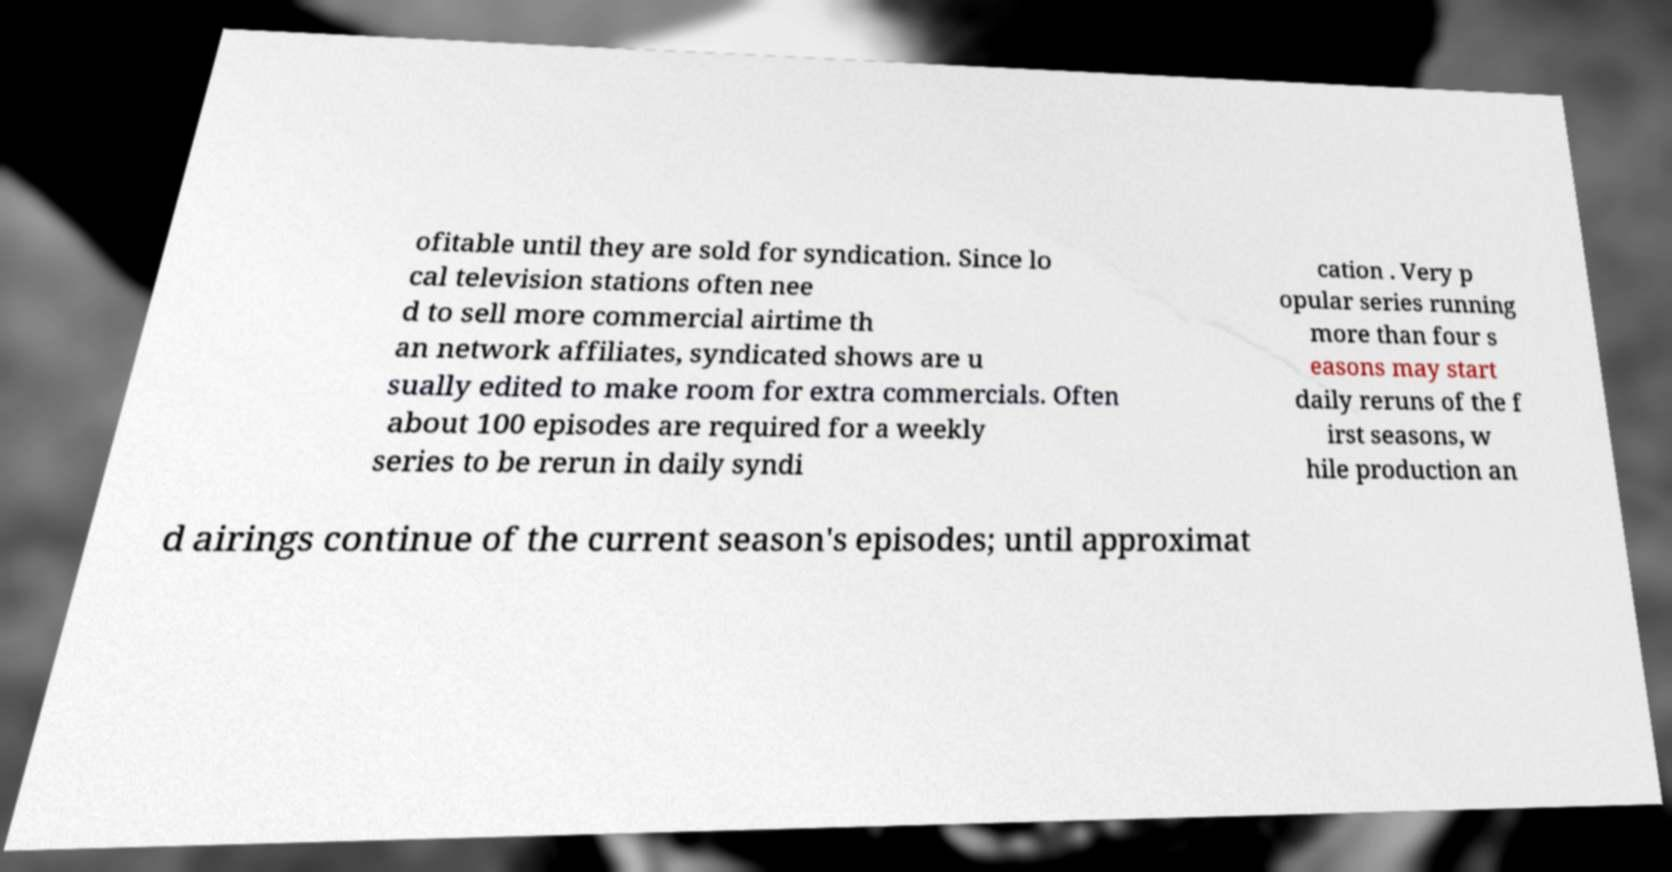Can you accurately transcribe the text from the provided image for me? ofitable until they are sold for syndication. Since lo cal television stations often nee d to sell more commercial airtime th an network affiliates, syndicated shows are u sually edited to make room for extra commercials. Often about 100 episodes are required for a weekly series to be rerun in daily syndi cation . Very p opular series running more than four s easons may start daily reruns of the f irst seasons, w hile production an d airings continue of the current season's episodes; until approximat 